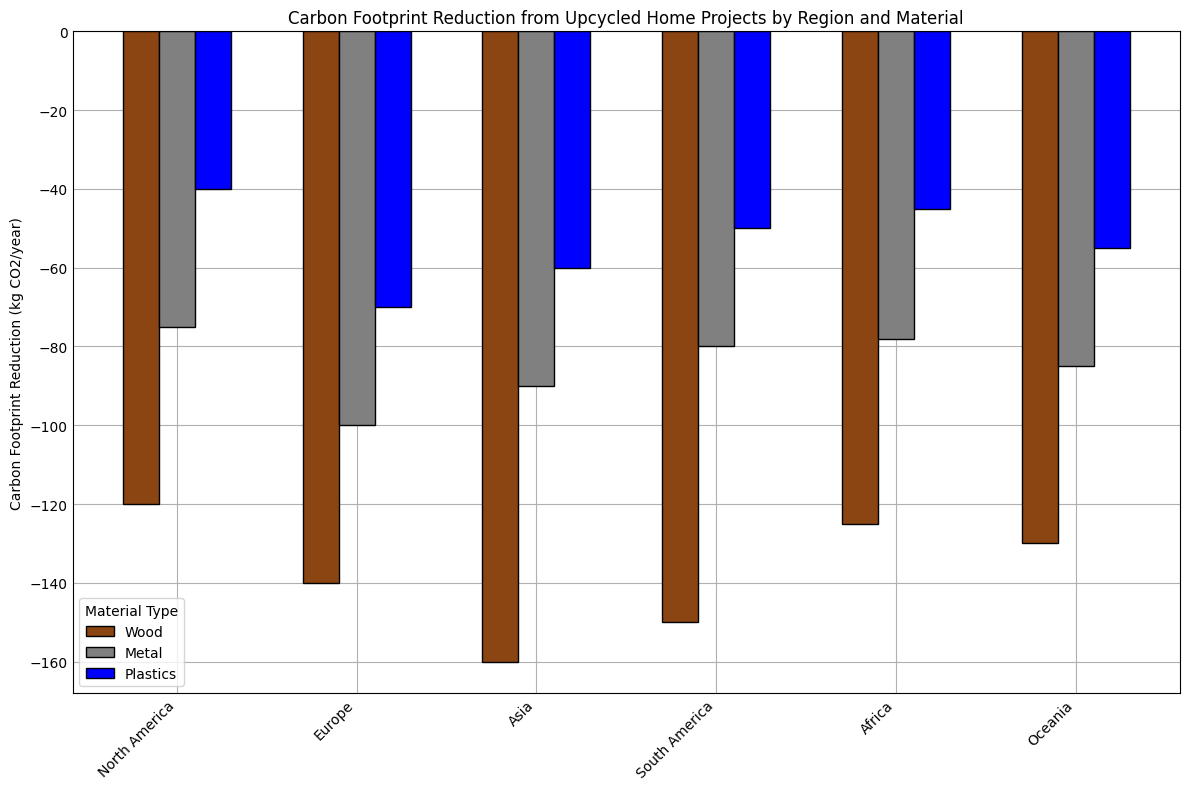What region has the highest carbon footprint reduction for wood? Observing the heights of the bars representing wood reduction across all regions, Europe has the tallest bar indicating the highest reduction.
Answer: Europe Which material has the lowest carbon footprint reduction in Asia? By comparing the bar heights in Asia, the plastic bar is the shortest, indicating the lowest reduction.
Answer: Plastics What is the total carbon footprint reduction for metal across all regions? Adding the carbon footprint reductions for metal in each region: -80 (North America) + -90 (Europe) + -100 (Asia) + -85 (South America) + -75 (Africa) + -78 (Oceania) = -508 kg CO2/year.
Answer: -508 By how much does the carbon footprint reduction of wood in Europe exceed that in North America? Subtract the reduction amount of wood in North America from that in Europe: -160 (Europe) - (-150) (North America) = -160 + 150 = -10 kg CO2/year.
Answer: 10 Which region shows the smallest reduction for plastics? Comparing the heights of the plastic bars across all regions, Africa has the smallest reduction.
Answer: Africa In North America, which material has the second highest reduction in the carbon footprint? In North America, the bars show the highest reduction for wood, followed by metal, then plastics. Thus, metal has the second highest reduction.
Answer: Metal What is the average carbon footprint reduction for plastics across all regions? Sum the reductions for plastics across all regions and divide by the number of regions: (-50 + -60 + -70 + -55 + -40 + -45) / 6 = -320 / 6 ≈ -53.33 kg CO2/year.
Answer: -53.33 How does the reduction of metal in South America compare to that in Oceania? Comparing the heights of the metal bars in South America and Oceania, South America's reduction is -85, while Oceania's is -78. South America's reduction is greater.
Answer: Greater Rank the regions from highest to lowest carbon footprint reduction for wood. Observing the wood bars, the order from highest to lowest reduction is: Europe (-160), North America (-150), Asia (-140), Oceania (-125), South America (-130), Africa (-120).
Answer: Europe, North America, Asia, South America, Oceania, Africa By what percentage does the carbon footprint reduction for metal in Asia exceed that in North America? Calculate the percentage increase: ([-100 - (-80)] / -80) * 100% = ((-100 + 80) / -80) * 100% = (-20 / -80) * 100% = 25%.
Answer: 25% 